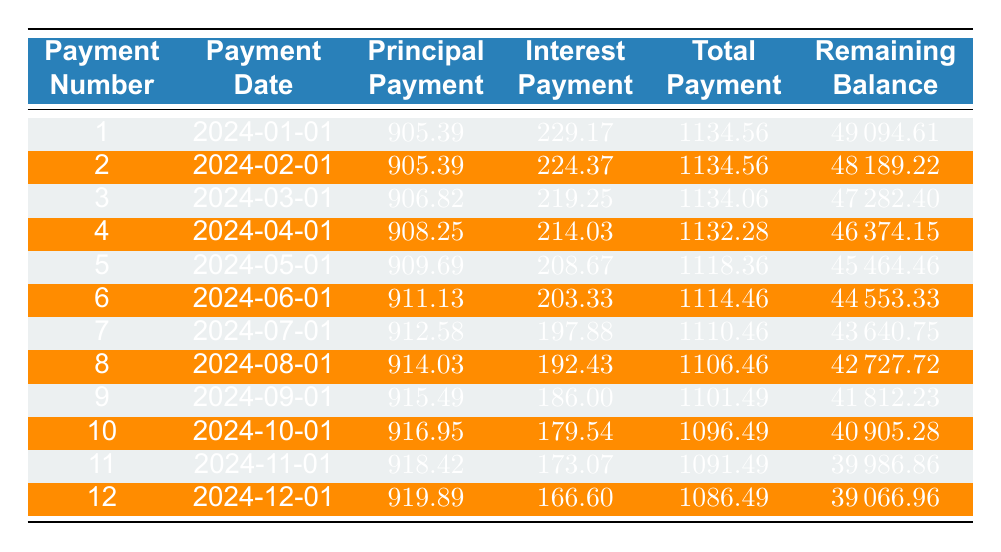What is the total payment for the first month? To find the total payment for the first month, we can refer to the first row of the table, where the total payment listed is 1134.56.
Answer: 1134.56 What is the principal payment amount for the sixth payment? Referring to the sixth entry in the table, the principal payment amount is 911.13.
Answer: 911.13 Is the interest payment for the tenth payment greater than 180? Looking at the table, the interest payment for the tenth payment is 179.54, which is not greater than 180. Therefore, the answer is no.
Answer: No What is the remaining balance after the fifth payment? The fifth entry shows that after the fifth payment, the remaining balance is 45464.46.
Answer: 45464.46 What is the average principal payment over the first twelve payments? The principal payments from the first twelve entries are summed: (905.39 + 905.39 + 906.82 + 908.25 + 909.69 + 911.13 + 912.58 + 914.03 + 915.49 + 916.95 + 918.42 + 919.89) = 10912.09. There are 12 payments, so the average is 10912.09 / 12 = 909.34.
Answer: 909.34 What is the difference between the total payment of the first and second payments? The total payment for the first payment is 1134.56 and the second payment is also 1134.56. The difference between the two is 1134.56 - 1134.56 = 0.
Answer: 0 Is the total payment for the fourth payment less than the total payment for the fifth payment? By looking at the fourth and fifth payments in the table, the total payment for the fourth payment is 1132.28, and for the fifth payment, it is 1118.36. Since 1132.28 is greater than 1118.36, the answer is no.
Answer: No What is the highest principal payment made in the first twelve months? Scanning through the principal payment column of the first twelve payments, the highest payment is found to be 919.89 from the twelfth payment.
Answer: 919.89 What is the total interest paid in the first three payments? Adding the interest payments for the first three rows: (229.17 + 224.37 + 219.25) = 672.79. Therefore, the total interest paid in the first three payments is 672.79.
Answer: 672.79 